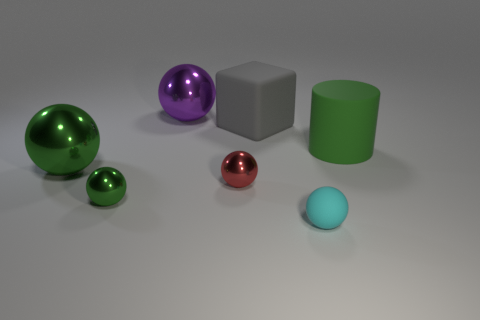Are there any other things that are the same color as the big cylinder?
Ensure brevity in your answer.  Yes. Is the number of tiny red shiny spheres on the left side of the big green metal object greater than the number of big matte cubes in front of the cylinder?
Provide a short and direct response. No. How many cyan rubber things have the same size as the gray cube?
Your answer should be compact. 0. Is the number of gray objects that are left of the large purple metal object less than the number of green shiny spheres that are in front of the tiny green sphere?
Provide a succinct answer. No. Are there any other metallic objects that have the same shape as the large green metallic object?
Provide a short and direct response. Yes. Is the big purple metallic thing the same shape as the gray object?
Give a very brief answer. No. What number of big objects are gray rubber balls or red objects?
Offer a very short reply. 0. Are there more large spheres than large gray rubber blocks?
Offer a terse response. Yes. The ball that is made of the same material as the large gray object is what size?
Make the answer very short. Small. Do the purple sphere behind the rubber cylinder and the metallic thing that is in front of the red shiny ball have the same size?
Your answer should be very brief. No. 